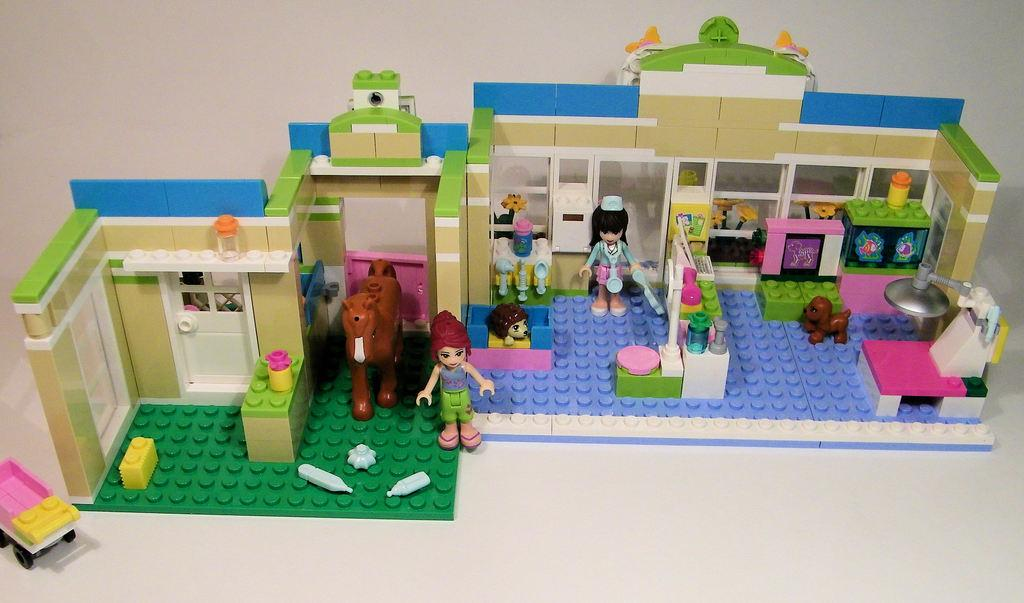What type of structure is in the image? There is a toy house in the image. Who or what else is in the image? There is a person and animals in the image. What piece of furniture is in the image? There is a table in the image. Are there any other objects on the floor in the image? Other objects may be present on the floor in the image. Where might this image have been taken? The image may have been taken in a hall. What type of mark can be seen on the tongue of the person in the image? There is no mention of a mark on the tongue of the person in the image, nor is there any indication of a tongue being visible. How many eggs are present in the image? There is no mention of eggs in the image, so it is impossible to determine their quantity. 